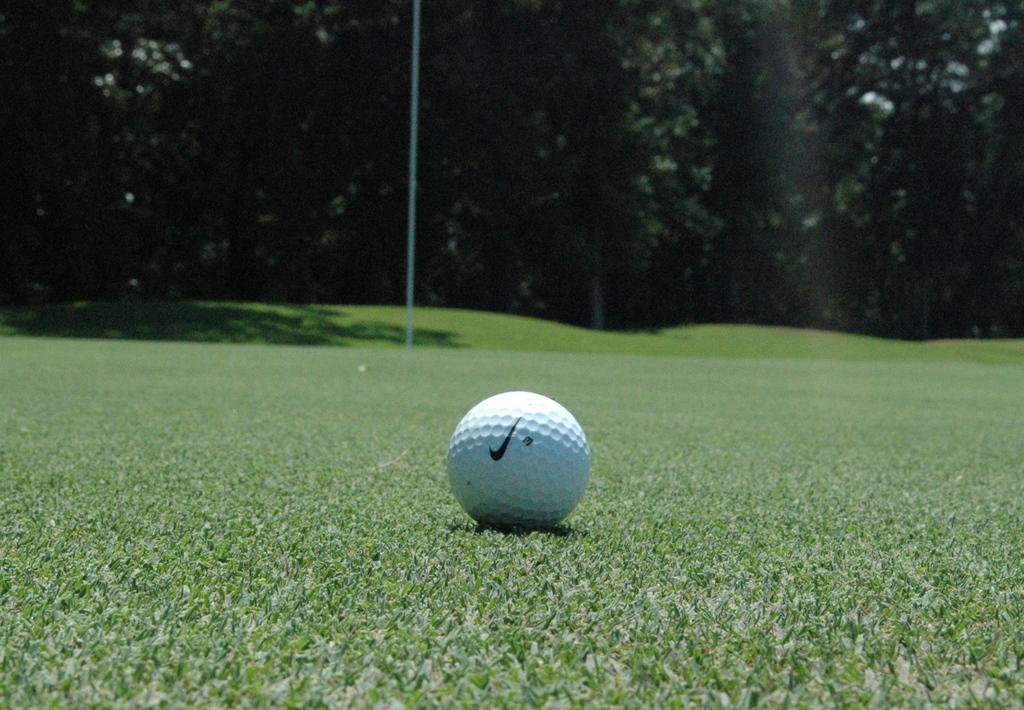Can you describe this image briefly? In this image we can see one white golf ball on the ground, one pole on the ground, background there are some trees and some green grass on the ground. 